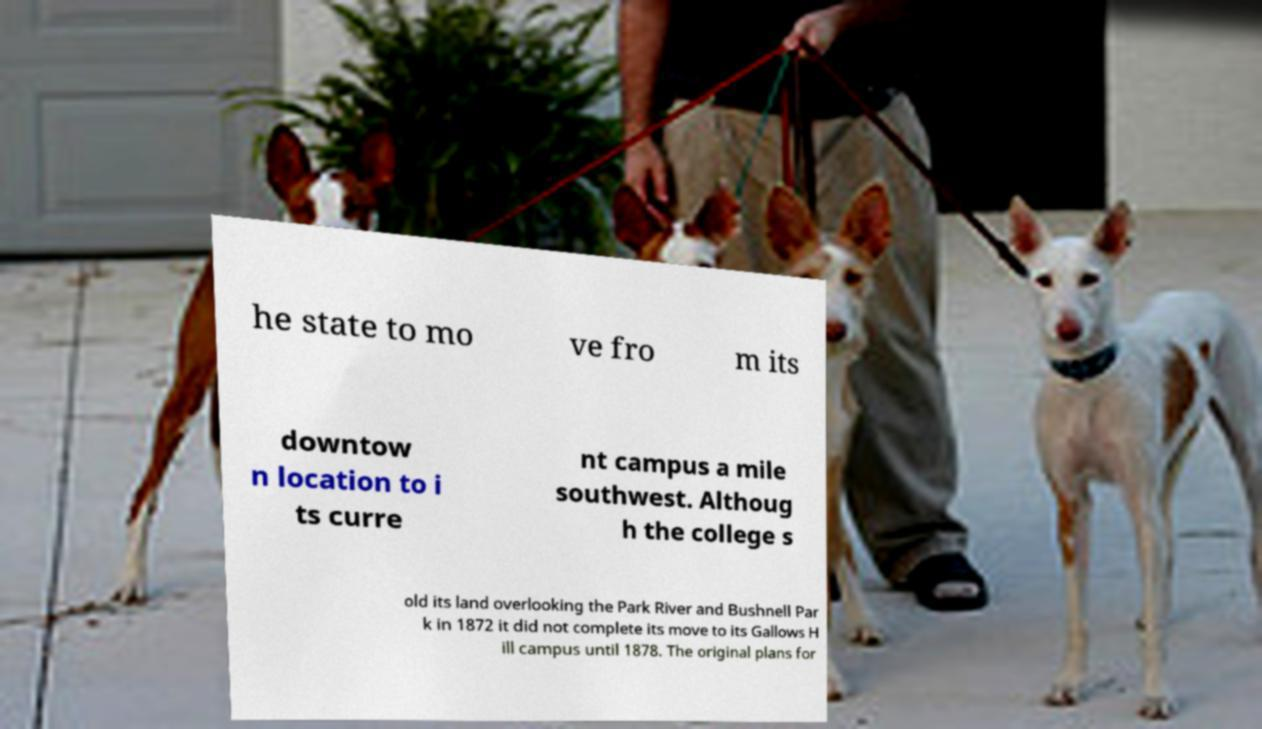Could you extract and type out the text from this image? he state to mo ve fro m its downtow n location to i ts curre nt campus a mile southwest. Althoug h the college s old its land overlooking the Park River and Bushnell Par k in 1872 it did not complete its move to its Gallows H ill campus until 1878. The original plans for 